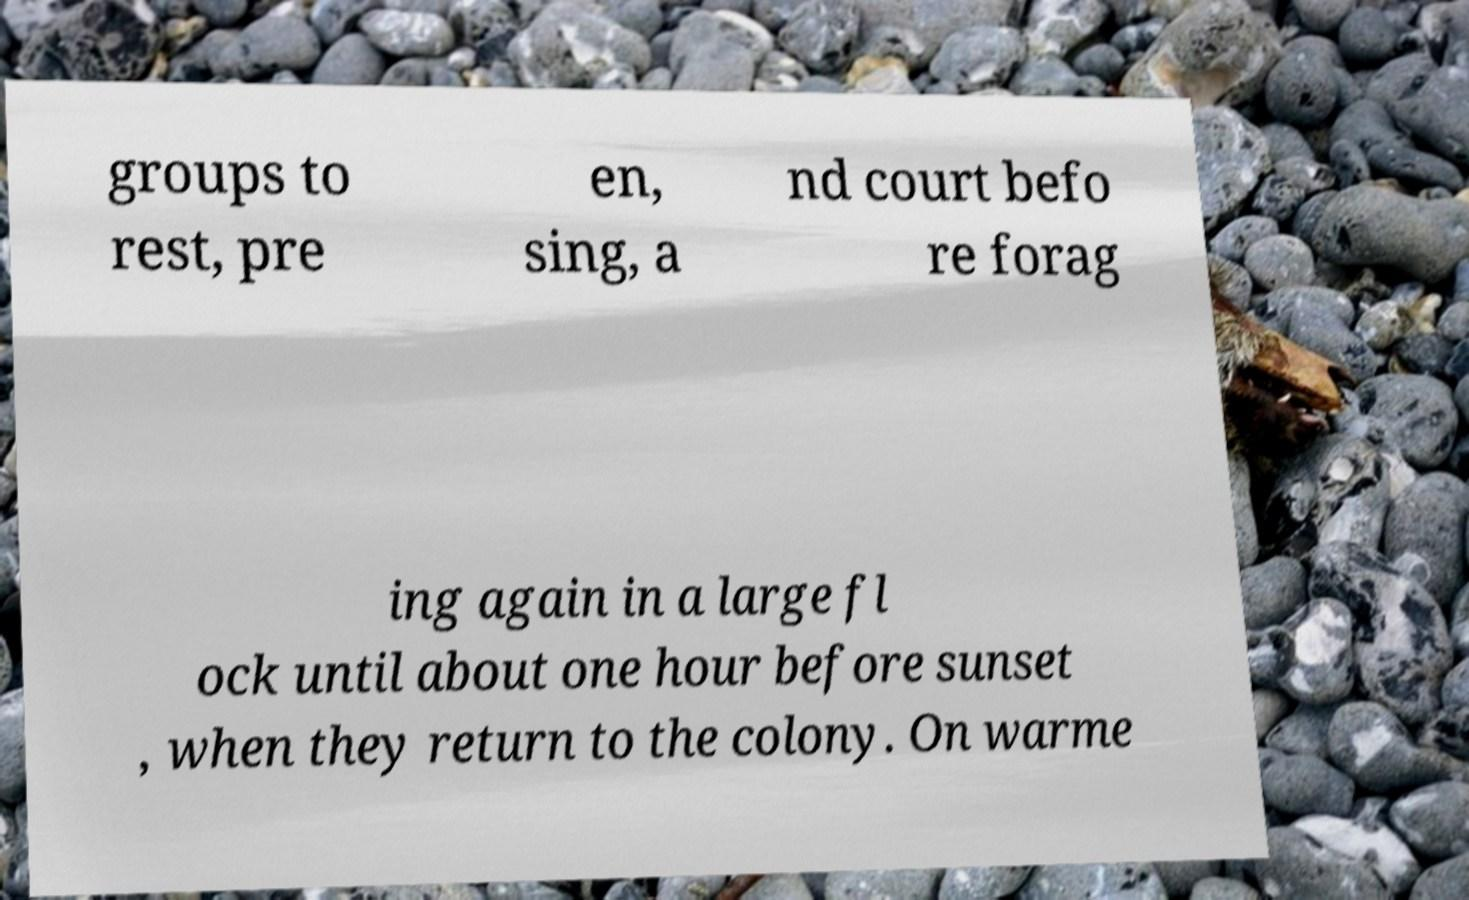There's text embedded in this image that I need extracted. Can you transcribe it verbatim? groups to rest, pre en, sing, a nd court befo re forag ing again in a large fl ock until about one hour before sunset , when they return to the colony. On warme 